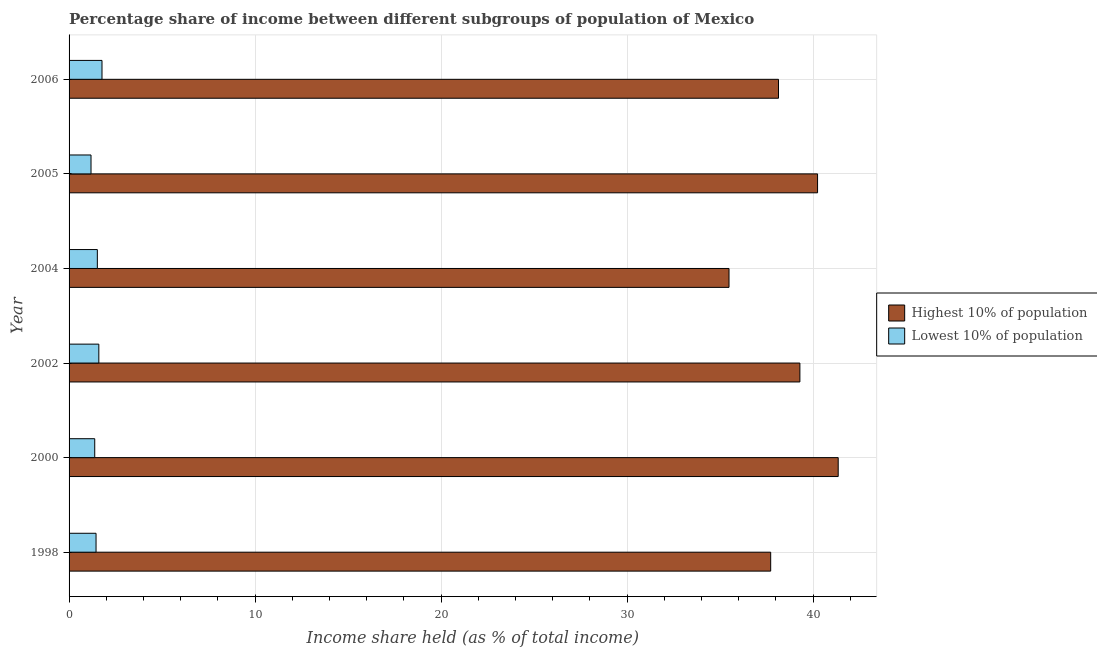How many different coloured bars are there?
Ensure brevity in your answer.  2. How many groups of bars are there?
Keep it short and to the point. 6. How many bars are there on the 3rd tick from the top?
Your response must be concise. 2. How many bars are there on the 5th tick from the bottom?
Your response must be concise. 2. In how many cases, is the number of bars for a given year not equal to the number of legend labels?
Your answer should be very brief. 0. What is the income share held by highest 10% of the population in 2002?
Offer a very short reply. 39.29. Across all years, what is the maximum income share held by lowest 10% of the population?
Provide a short and direct response. 1.77. Across all years, what is the minimum income share held by lowest 10% of the population?
Your answer should be very brief. 1.18. In which year was the income share held by lowest 10% of the population maximum?
Your response must be concise. 2006. What is the total income share held by highest 10% of the population in the graph?
Provide a succinct answer. 232.22. What is the difference between the income share held by lowest 10% of the population in 1998 and that in 2005?
Offer a very short reply. 0.27. What is the difference between the income share held by lowest 10% of the population in 2002 and the income share held by highest 10% of the population in 1998?
Your answer should be very brief. -36.12. What is the average income share held by lowest 10% of the population per year?
Provide a short and direct response. 1.48. In the year 2004, what is the difference between the income share held by highest 10% of the population and income share held by lowest 10% of the population?
Provide a succinct answer. 33.96. What is the ratio of the income share held by highest 10% of the population in 1998 to that in 2004?
Make the answer very short. 1.06. What is the difference between the highest and the second highest income share held by lowest 10% of the population?
Keep it short and to the point. 0.17. What is the difference between the highest and the lowest income share held by highest 10% of the population?
Provide a short and direct response. 5.87. In how many years, is the income share held by lowest 10% of the population greater than the average income share held by lowest 10% of the population taken over all years?
Your answer should be compact. 3. What does the 1st bar from the top in 2005 represents?
Offer a terse response. Lowest 10% of population. What does the 1st bar from the bottom in 2002 represents?
Offer a terse response. Highest 10% of population. How many bars are there?
Your answer should be compact. 12. Are all the bars in the graph horizontal?
Your answer should be very brief. Yes. How many legend labels are there?
Your answer should be very brief. 2. What is the title of the graph?
Offer a terse response. Percentage share of income between different subgroups of population of Mexico. What is the label or title of the X-axis?
Your answer should be compact. Income share held (as % of total income). What is the label or title of the Y-axis?
Offer a terse response. Year. What is the Income share held (as % of total income) of Highest 10% of population in 1998?
Provide a succinct answer. 37.72. What is the Income share held (as % of total income) in Lowest 10% of population in 1998?
Your answer should be very brief. 1.45. What is the Income share held (as % of total income) in Highest 10% of population in 2000?
Make the answer very short. 41.35. What is the Income share held (as % of total income) in Lowest 10% of population in 2000?
Offer a terse response. 1.38. What is the Income share held (as % of total income) of Highest 10% of population in 2002?
Give a very brief answer. 39.29. What is the Income share held (as % of total income) of Lowest 10% of population in 2002?
Give a very brief answer. 1.6. What is the Income share held (as % of total income) in Highest 10% of population in 2004?
Keep it short and to the point. 35.48. What is the Income share held (as % of total income) of Lowest 10% of population in 2004?
Keep it short and to the point. 1.52. What is the Income share held (as % of total income) of Highest 10% of population in 2005?
Offer a terse response. 40.24. What is the Income share held (as % of total income) in Lowest 10% of population in 2005?
Offer a very short reply. 1.18. What is the Income share held (as % of total income) in Highest 10% of population in 2006?
Your answer should be very brief. 38.14. What is the Income share held (as % of total income) of Lowest 10% of population in 2006?
Provide a short and direct response. 1.77. Across all years, what is the maximum Income share held (as % of total income) of Highest 10% of population?
Give a very brief answer. 41.35. Across all years, what is the maximum Income share held (as % of total income) of Lowest 10% of population?
Offer a terse response. 1.77. Across all years, what is the minimum Income share held (as % of total income) of Highest 10% of population?
Ensure brevity in your answer.  35.48. Across all years, what is the minimum Income share held (as % of total income) in Lowest 10% of population?
Offer a very short reply. 1.18. What is the total Income share held (as % of total income) of Highest 10% of population in the graph?
Keep it short and to the point. 232.22. What is the total Income share held (as % of total income) in Lowest 10% of population in the graph?
Your answer should be compact. 8.9. What is the difference between the Income share held (as % of total income) of Highest 10% of population in 1998 and that in 2000?
Ensure brevity in your answer.  -3.63. What is the difference between the Income share held (as % of total income) in Lowest 10% of population in 1998 and that in 2000?
Provide a succinct answer. 0.07. What is the difference between the Income share held (as % of total income) of Highest 10% of population in 1998 and that in 2002?
Provide a short and direct response. -1.57. What is the difference between the Income share held (as % of total income) in Highest 10% of population in 1998 and that in 2004?
Provide a succinct answer. 2.24. What is the difference between the Income share held (as % of total income) in Lowest 10% of population in 1998 and that in 2004?
Provide a short and direct response. -0.07. What is the difference between the Income share held (as % of total income) in Highest 10% of population in 1998 and that in 2005?
Provide a succinct answer. -2.52. What is the difference between the Income share held (as % of total income) in Lowest 10% of population in 1998 and that in 2005?
Offer a very short reply. 0.27. What is the difference between the Income share held (as % of total income) in Highest 10% of population in 1998 and that in 2006?
Your response must be concise. -0.42. What is the difference between the Income share held (as % of total income) of Lowest 10% of population in 1998 and that in 2006?
Provide a succinct answer. -0.32. What is the difference between the Income share held (as % of total income) in Highest 10% of population in 2000 and that in 2002?
Provide a short and direct response. 2.06. What is the difference between the Income share held (as % of total income) of Lowest 10% of population in 2000 and that in 2002?
Your response must be concise. -0.22. What is the difference between the Income share held (as % of total income) in Highest 10% of population in 2000 and that in 2004?
Offer a terse response. 5.87. What is the difference between the Income share held (as % of total income) in Lowest 10% of population in 2000 and that in 2004?
Offer a terse response. -0.14. What is the difference between the Income share held (as % of total income) in Highest 10% of population in 2000 and that in 2005?
Give a very brief answer. 1.11. What is the difference between the Income share held (as % of total income) in Lowest 10% of population in 2000 and that in 2005?
Provide a succinct answer. 0.2. What is the difference between the Income share held (as % of total income) in Highest 10% of population in 2000 and that in 2006?
Give a very brief answer. 3.21. What is the difference between the Income share held (as % of total income) of Lowest 10% of population in 2000 and that in 2006?
Make the answer very short. -0.39. What is the difference between the Income share held (as % of total income) of Highest 10% of population in 2002 and that in 2004?
Offer a terse response. 3.81. What is the difference between the Income share held (as % of total income) of Lowest 10% of population in 2002 and that in 2004?
Give a very brief answer. 0.08. What is the difference between the Income share held (as % of total income) of Highest 10% of population in 2002 and that in 2005?
Offer a terse response. -0.95. What is the difference between the Income share held (as % of total income) in Lowest 10% of population in 2002 and that in 2005?
Your answer should be very brief. 0.42. What is the difference between the Income share held (as % of total income) in Highest 10% of population in 2002 and that in 2006?
Your response must be concise. 1.15. What is the difference between the Income share held (as % of total income) of Lowest 10% of population in 2002 and that in 2006?
Your answer should be very brief. -0.17. What is the difference between the Income share held (as % of total income) in Highest 10% of population in 2004 and that in 2005?
Offer a very short reply. -4.76. What is the difference between the Income share held (as % of total income) of Lowest 10% of population in 2004 and that in 2005?
Your answer should be compact. 0.34. What is the difference between the Income share held (as % of total income) in Highest 10% of population in 2004 and that in 2006?
Your response must be concise. -2.66. What is the difference between the Income share held (as % of total income) in Lowest 10% of population in 2004 and that in 2006?
Your response must be concise. -0.25. What is the difference between the Income share held (as % of total income) of Highest 10% of population in 2005 and that in 2006?
Ensure brevity in your answer.  2.1. What is the difference between the Income share held (as % of total income) of Lowest 10% of population in 2005 and that in 2006?
Ensure brevity in your answer.  -0.59. What is the difference between the Income share held (as % of total income) in Highest 10% of population in 1998 and the Income share held (as % of total income) in Lowest 10% of population in 2000?
Your answer should be very brief. 36.34. What is the difference between the Income share held (as % of total income) of Highest 10% of population in 1998 and the Income share held (as % of total income) of Lowest 10% of population in 2002?
Your response must be concise. 36.12. What is the difference between the Income share held (as % of total income) of Highest 10% of population in 1998 and the Income share held (as % of total income) of Lowest 10% of population in 2004?
Offer a very short reply. 36.2. What is the difference between the Income share held (as % of total income) of Highest 10% of population in 1998 and the Income share held (as % of total income) of Lowest 10% of population in 2005?
Your answer should be very brief. 36.54. What is the difference between the Income share held (as % of total income) of Highest 10% of population in 1998 and the Income share held (as % of total income) of Lowest 10% of population in 2006?
Your answer should be compact. 35.95. What is the difference between the Income share held (as % of total income) in Highest 10% of population in 2000 and the Income share held (as % of total income) in Lowest 10% of population in 2002?
Give a very brief answer. 39.75. What is the difference between the Income share held (as % of total income) of Highest 10% of population in 2000 and the Income share held (as % of total income) of Lowest 10% of population in 2004?
Keep it short and to the point. 39.83. What is the difference between the Income share held (as % of total income) in Highest 10% of population in 2000 and the Income share held (as % of total income) in Lowest 10% of population in 2005?
Offer a very short reply. 40.17. What is the difference between the Income share held (as % of total income) of Highest 10% of population in 2000 and the Income share held (as % of total income) of Lowest 10% of population in 2006?
Ensure brevity in your answer.  39.58. What is the difference between the Income share held (as % of total income) in Highest 10% of population in 2002 and the Income share held (as % of total income) in Lowest 10% of population in 2004?
Offer a terse response. 37.77. What is the difference between the Income share held (as % of total income) in Highest 10% of population in 2002 and the Income share held (as % of total income) in Lowest 10% of population in 2005?
Your answer should be compact. 38.11. What is the difference between the Income share held (as % of total income) of Highest 10% of population in 2002 and the Income share held (as % of total income) of Lowest 10% of population in 2006?
Provide a short and direct response. 37.52. What is the difference between the Income share held (as % of total income) in Highest 10% of population in 2004 and the Income share held (as % of total income) in Lowest 10% of population in 2005?
Your answer should be very brief. 34.3. What is the difference between the Income share held (as % of total income) of Highest 10% of population in 2004 and the Income share held (as % of total income) of Lowest 10% of population in 2006?
Your answer should be very brief. 33.71. What is the difference between the Income share held (as % of total income) of Highest 10% of population in 2005 and the Income share held (as % of total income) of Lowest 10% of population in 2006?
Your response must be concise. 38.47. What is the average Income share held (as % of total income) of Highest 10% of population per year?
Offer a very short reply. 38.7. What is the average Income share held (as % of total income) in Lowest 10% of population per year?
Make the answer very short. 1.48. In the year 1998, what is the difference between the Income share held (as % of total income) in Highest 10% of population and Income share held (as % of total income) in Lowest 10% of population?
Keep it short and to the point. 36.27. In the year 2000, what is the difference between the Income share held (as % of total income) in Highest 10% of population and Income share held (as % of total income) in Lowest 10% of population?
Offer a terse response. 39.97. In the year 2002, what is the difference between the Income share held (as % of total income) of Highest 10% of population and Income share held (as % of total income) of Lowest 10% of population?
Your answer should be compact. 37.69. In the year 2004, what is the difference between the Income share held (as % of total income) of Highest 10% of population and Income share held (as % of total income) of Lowest 10% of population?
Offer a very short reply. 33.96. In the year 2005, what is the difference between the Income share held (as % of total income) in Highest 10% of population and Income share held (as % of total income) in Lowest 10% of population?
Keep it short and to the point. 39.06. In the year 2006, what is the difference between the Income share held (as % of total income) of Highest 10% of population and Income share held (as % of total income) of Lowest 10% of population?
Offer a very short reply. 36.37. What is the ratio of the Income share held (as % of total income) of Highest 10% of population in 1998 to that in 2000?
Make the answer very short. 0.91. What is the ratio of the Income share held (as % of total income) of Lowest 10% of population in 1998 to that in 2000?
Make the answer very short. 1.05. What is the ratio of the Income share held (as % of total income) in Highest 10% of population in 1998 to that in 2002?
Ensure brevity in your answer.  0.96. What is the ratio of the Income share held (as % of total income) of Lowest 10% of population in 1998 to that in 2002?
Provide a short and direct response. 0.91. What is the ratio of the Income share held (as % of total income) in Highest 10% of population in 1998 to that in 2004?
Provide a succinct answer. 1.06. What is the ratio of the Income share held (as % of total income) in Lowest 10% of population in 1998 to that in 2004?
Give a very brief answer. 0.95. What is the ratio of the Income share held (as % of total income) in Highest 10% of population in 1998 to that in 2005?
Your answer should be compact. 0.94. What is the ratio of the Income share held (as % of total income) of Lowest 10% of population in 1998 to that in 2005?
Give a very brief answer. 1.23. What is the ratio of the Income share held (as % of total income) of Lowest 10% of population in 1998 to that in 2006?
Ensure brevity in your answer.  0.82. What is the ratio of the Income share held (as % of total income) in Highest 10% of population in 2000 to that in 2002?
Your answer should be very brief. 1.05. What is the ratio of the Income share held (as % of total income) of Lowest 10% of population in 2000 to that in 2002?
Make the answer very short. 0.86. What is the ratio of the Income share held (as % of total income) in Highest 10% of population in 2000 to that in 2004?
Keep it short and to the point. 1.17. What is the ratio of the Income share held (as % of total income) in Lowest 10% of population in 2000 to that in 2004?
Your response must be concise. 0.91. What is the ratio of the Income share held (as % of total income) in Highest 10% of population in 2000 to that in 2005?
Your response must be concise. 1.03. What is the ratio of the Income share held (as % of total income) of Lowest 10% of population in 2000 to that in 2005?
Offer a very short reply. 1.17. What is the ratio of the Income share held (as % of total income) in Highest 10% of population in 2000 to that in 2006?
Offer a terse response. 1.08. What is the ratio of the Income share held (as % of total income) of Lowest 10% of population in 2000 to that in 2006?
Provide a succinct answer. 0.78. What is the ratio of the Income share held (as % of total income) of Highest 10% of population in 2002 to that in 2004?
Offer a very short reply. 1.11. What is the ratio of the Income share held (as % of total income) in Lowest 10% of population in 2002 to that in 2004?
Provide a succinct answer. 1.05. What is the ratio of the Income share held (as % of total income) in Highest 10% of population in 2002 to that in 2005?
Your answer should be compact. 0.98. What is the ratio of the Income share held (as % of total income) in Lowest 10% of population in 2002 to that in 2005?
Make the answer very short. 1.36. What is the ratio of the Income share held (as % of total income) of Highest 10% of population in 2002 to that in 2006?
Your answer should be compact. 1.03. What is the ratio of the Income share held (as % of total income) in Lowest 10% of population in 2002 to that in 2006?
Offer a terse response. 0.9. What is the ratio of the Income share held (as % of total income) in Highest 10% of population in 2004 to that in 2005?
Ensure brevity in your answer.  0.88. What is the ratio of the Income share held (as % of total income) of Lowest 10% of population in 2004 to that in 2005?
Offer a terse response. 1.29. What is the ratio of the Income share held (as % of total income) of Highest 10% of population in 2004 to that in 2006?
Your answer should be compact. 0.93. What is the ratio of the Income share held (as % of total income) in Lowest 10% of population in 2004 to that in 2006?
Offer a very short reply. 0.86. What is the ratio of the Income share held (as % of total income) in Highest 10% of population in 2005 to that in 2006?
Provide a succinct answer. 1.06. What is the difference between the highest and the second highest Income share held (as % of total income) of Highest 10% of population?
Your response must be concise. 1.11. What is the difference between the highest and the second highest Income share held (as % of total income) of Lowest 10% of population?
Keep it short and to the point. 0.17. What is the difference between the highest and the lowest Income share held (as % of total income) of Highest 10% of population?
Make the answer very short. 5.87. What is the difference between the highest and the lowest Income share held (as % of total income) of Lowest 10% of population?
Your answer should be very brief. 0.59. 